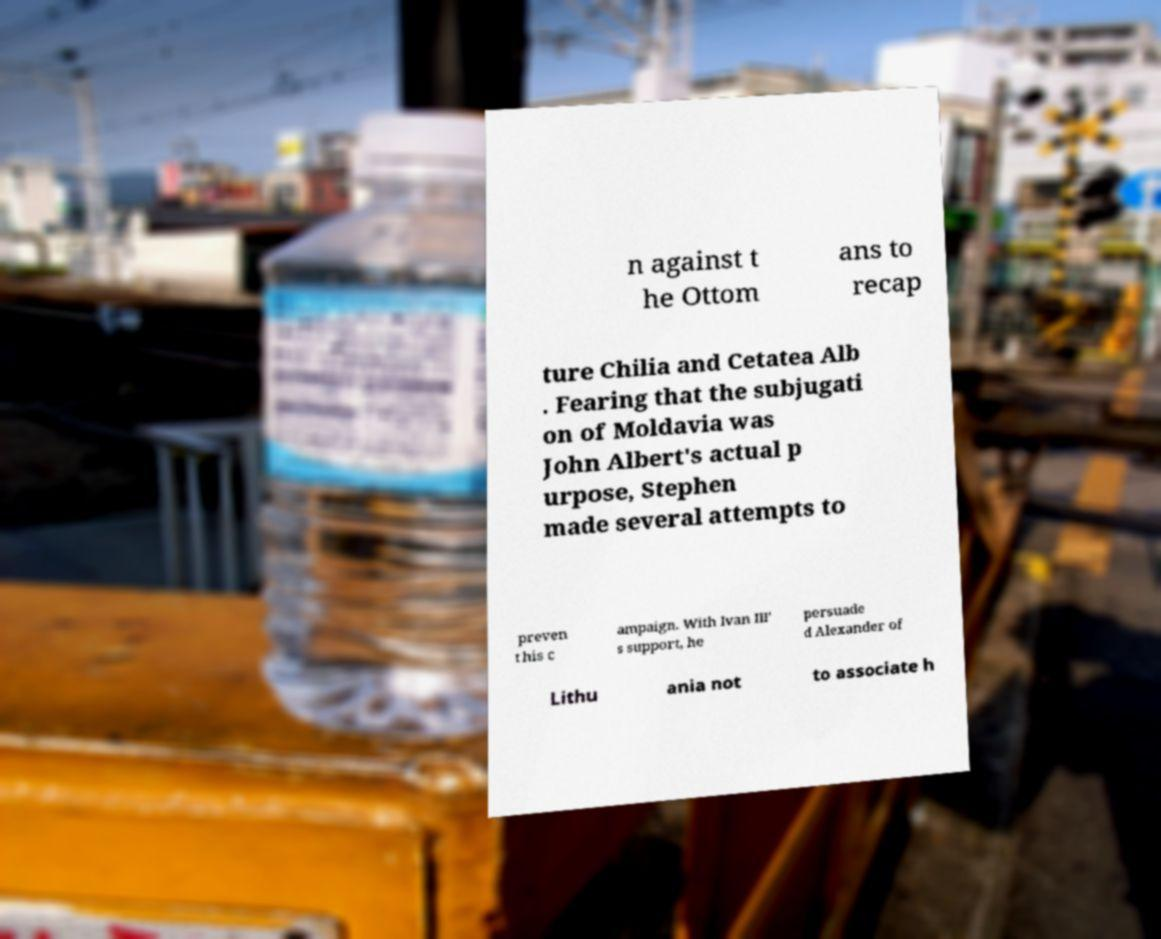Could you assist in decoding the text presented in this image and type it out clearly? n against t he Ottom ans to recap ture Chilia and Cetatea Alb . Fearing that the subjugati on of Moldavia was John Albert's actual p urpose, Stephen made several attempts to preven t his c ampaign. With Ivan III' s support, he persuade d Alexander of Lithu ania not to associate h 